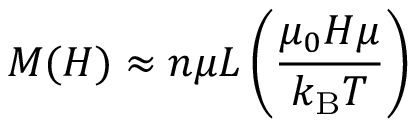Convert formula to latex. <formula><loc_0><loc_0><loc_500><loc_500>M ( H ) \approx n \mu L \left ( { \frac { \mu _ { 0 } H \mu } { k _ { B } T } } \right )</formula> 